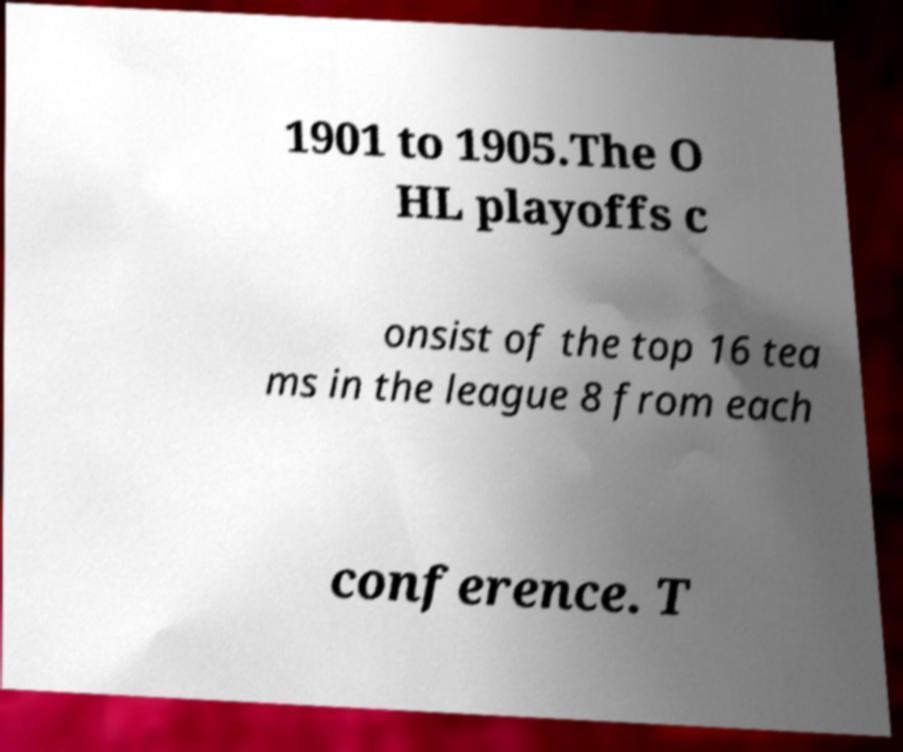There's text embedded in this image that I need extracted. Can you transcribe it verbatim? 1901 to 1905.The O HL playoffs c onsist of the top 16 tea ms in the league 8 from each conference. T 